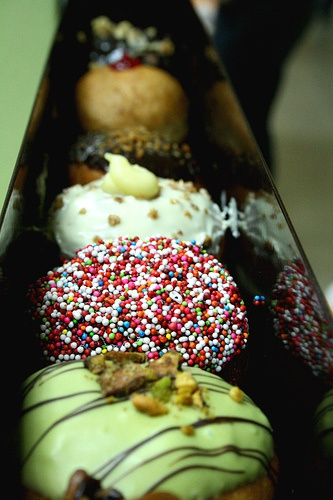Describe the objects in this image and their specific colors. I can see cake in lightgreen and olive tones, donut in lightgreen, olive, and darkgreen tones, donut in lightgreen, white, black, maroon, and brown tones, cake in lightgreen, white, black, maroon, and brown tones, and donut in lightgreen, beige, khaki, and darkgray tones in this image. 